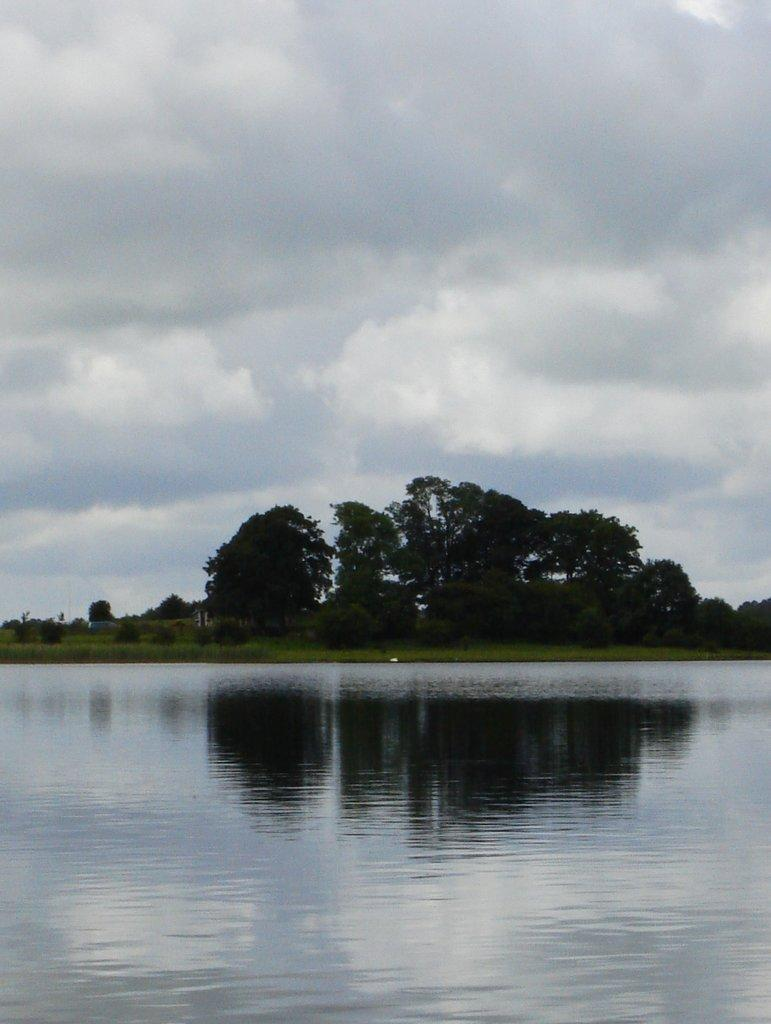What is the main element in the image? There is water in the image. What type of terrain is visible in the image? There is ground with grass in the image. What other natural elements can be seen in the image? There are trees in the image. What is visible above the ground and trees in the image? The sky is visible in the image. What can be observed in the sky? Clouds are present in the sky. How does the tin affect the water in the image? There is no tin present in the image, so it cannot affect the water. 